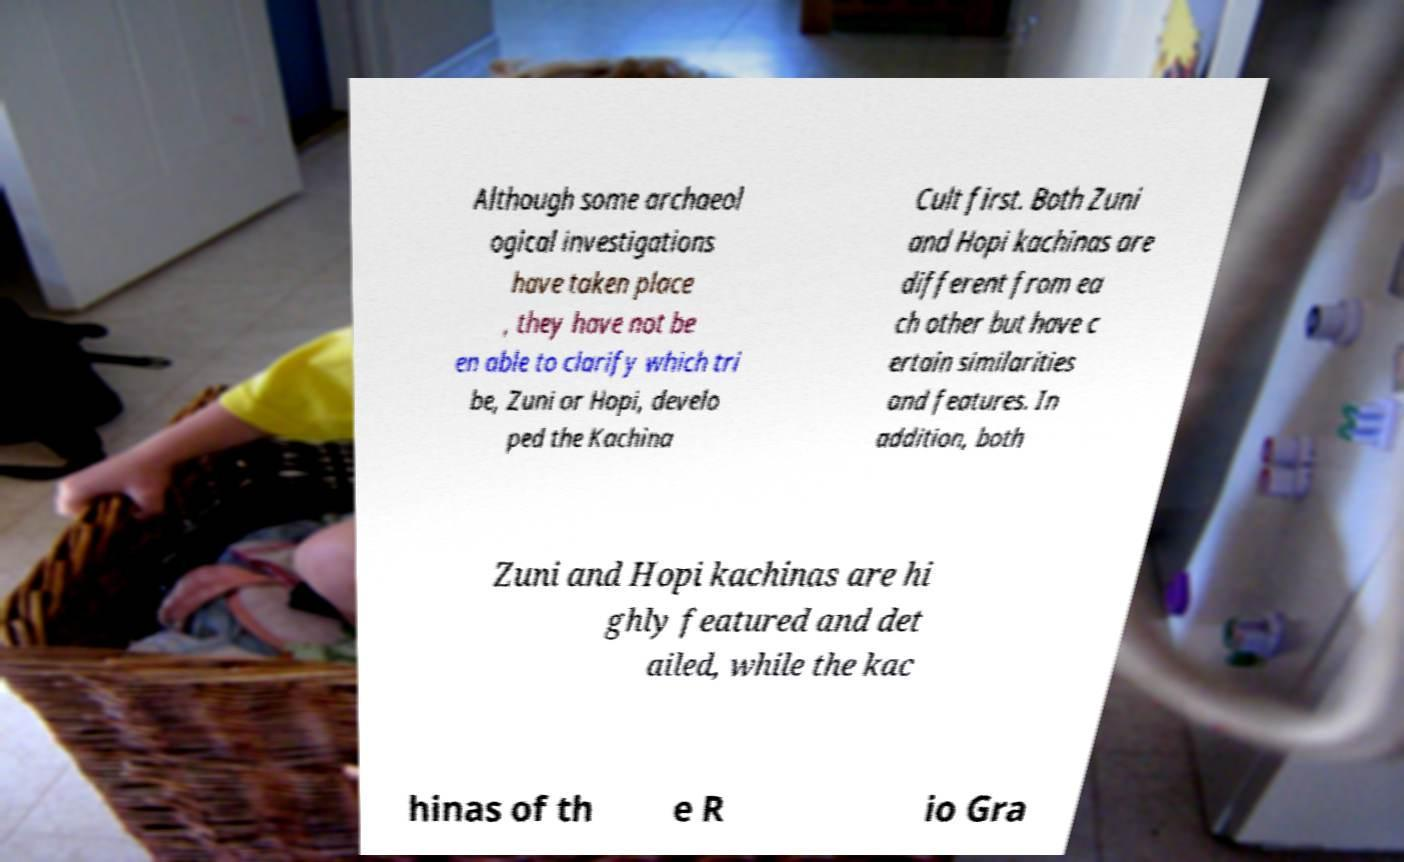Could you extract and type out the text from this image? Although some archaeol ogical investigations have taken place , they have not be en able to clarify which tri be, Zuni or Hopi, develo ped the Kachina Cult first. Both Zuni and Hopi kachinas are different from ea ch other but have c ertain similarities and features. In addition, both Zuni and Hopi kachinas are hi ghly featured and det ailed, while the kac hinas of th e R io Gra 